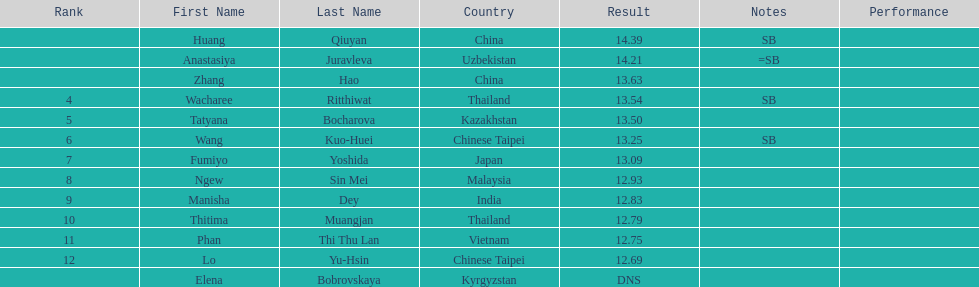How many athletes were from china? 2. 